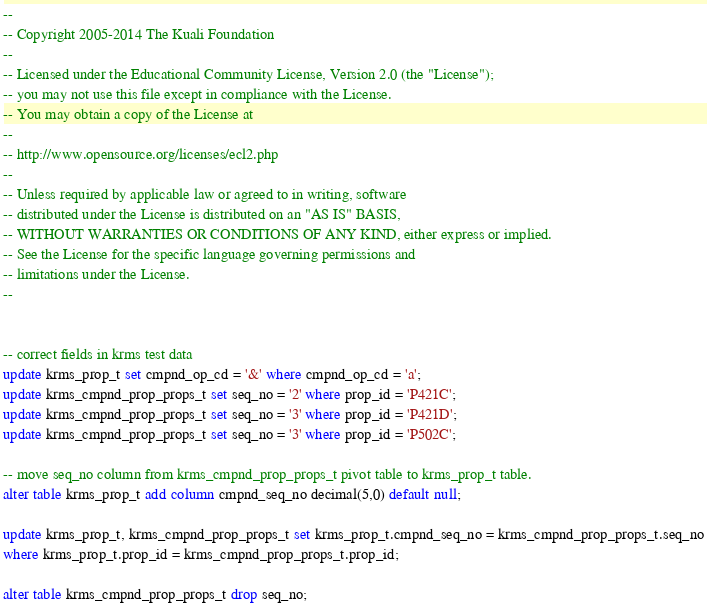<code> <loc_0><loc_0><loc_500><loc_500><_SQL_>--
-- Copyright 2005-2014 The Kuali Foundation
--
-- Licensed under the Educational Community License, Version 2.0 (the "License");
-- you may not use this file except in compliance with the License.
-- You may obtain a copy of the License at
--
-- http://www.opensource.org/licenses/ecl2.php
--
-- Unless required by applicable law or agreed to in writing, software
-- distributed under the License is distributed on an "AS IS" BASIS,
-- WITHOUT WARRANTIES OR CONDITIONS OF ANY KIND, either express or implied.
-- See the License for the specific language governing permissions and
-- limitations under the License.
--


-- correct fields in krms test data
update krms_prop_t set cmpnd_op_cd = '&' where cmpnd_op_cd = 'a';
update krms_cmpnd_prop_props_t set seq_no = '2' where prop_id = 'P421C';
update krms_cmpnd_prop_props_t set seq_no = '3' where prop_id = 'P421D';
update krms_cmpnd_prop_props_t set seq_no = '3' where prop_id = 'P502C';

-- move seq_no column from krms_cmpnd_prop_props_t pivot table to krms_prop_t table.
alter table krms_prop_t add column cmpnd_seq_no decimal(5,0) default null;

update krms_prop_t, krms_cmpnd_prop_props_t set krms_prop_t.cmpnd_seq_no = krms_cmpnd_prop_props_t.seq_no
where krms_prop_t.prop_id = krms_cmpnd_prop_props_t.prop_id;

alter table krms_cmpnd_prop_props_t drop seq_no;
</code> 